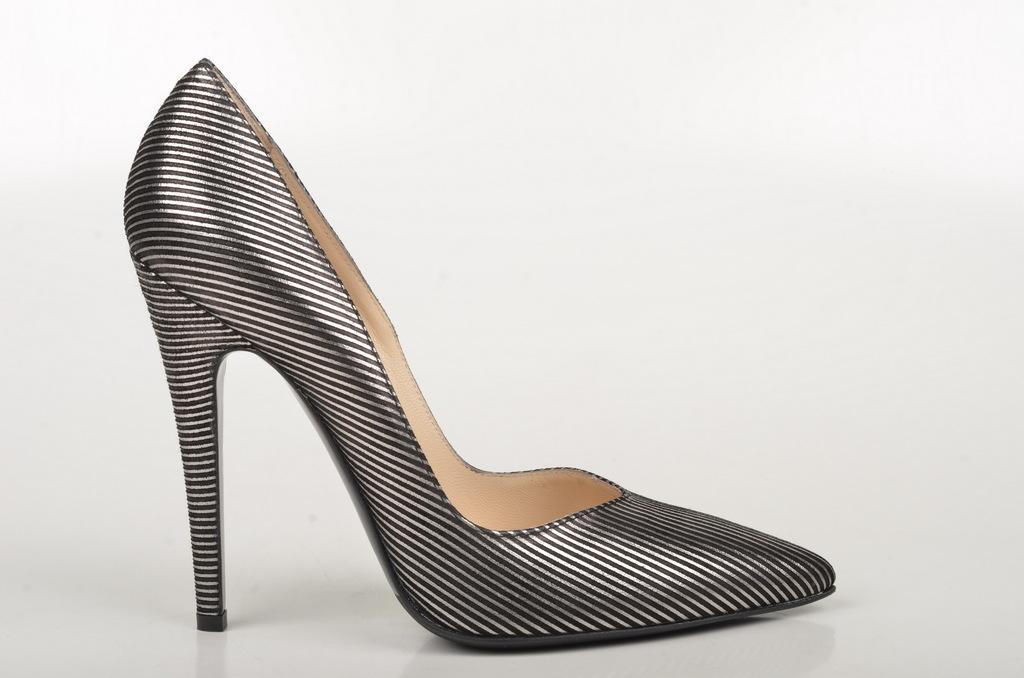What type of footwear is visible in the image? There is a black sandal in the image. Where is the sandal located in the image? The sandal is placed on the floor. What color is the background of the image? The background of the image is white. What is the average income of the patients in the hospital depicted in the image? There is no hospital or patients present in the image; it features a black sandal on a white background. 